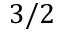<formula> <loc_0><loc_0><loc_500><loc_500>3 / 2</formula> 